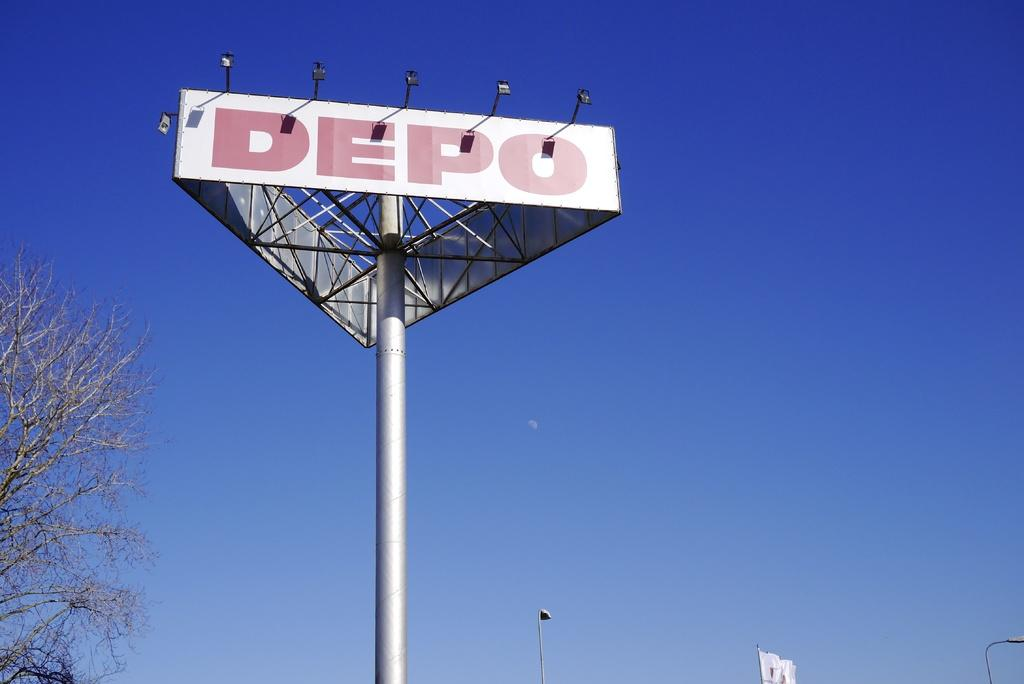<image>
Offer a succinct explanation of the picture presented. a triangular light pole with the word DEPO on it 